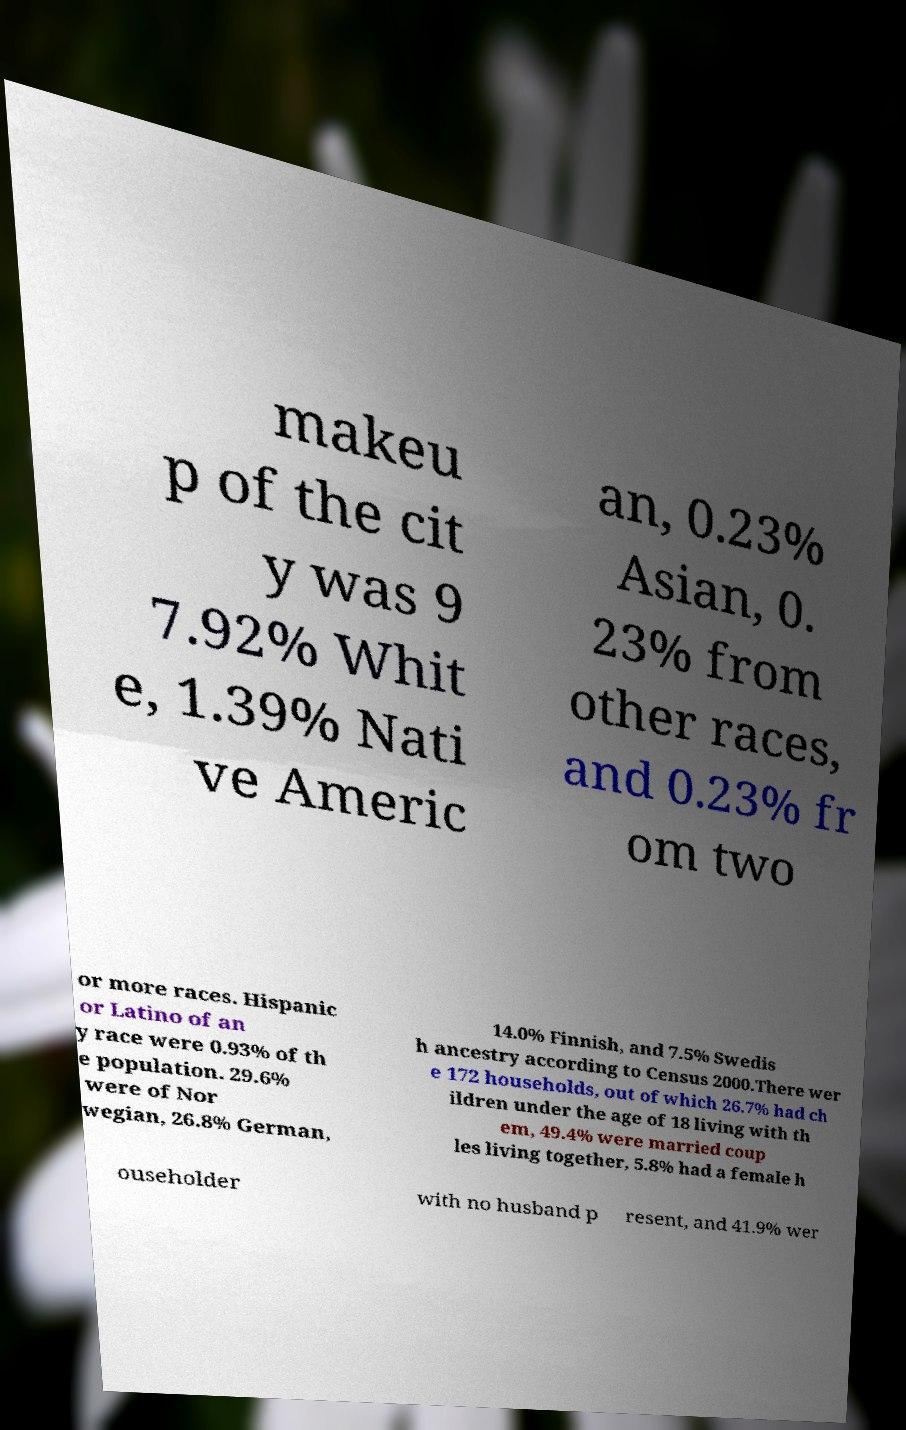There's text embedded in this image that I need extracted. Can you transcribe it verbatim? makeu p of the cit y was 9 7.92% Whit e, 1.39% Nati ve Americ an, 0.23% Asian, 0. 23% from other races, and 0.23% fr om two or more races. Hispanic or Latino of an y race were 0.93% of th e population. 29.6% were of Nor wegian, 26.8% German, 14.0% Finnish, and 7.5% Swedis h ancestry according to Census 2000.There wer e 172 households, out of which 26.7% had ch ildren under the age of 18 living with th em, 49.4% were married coup les living together, 5.8% had a female h ouseholder with no husband p resent, and 41.9% wer 